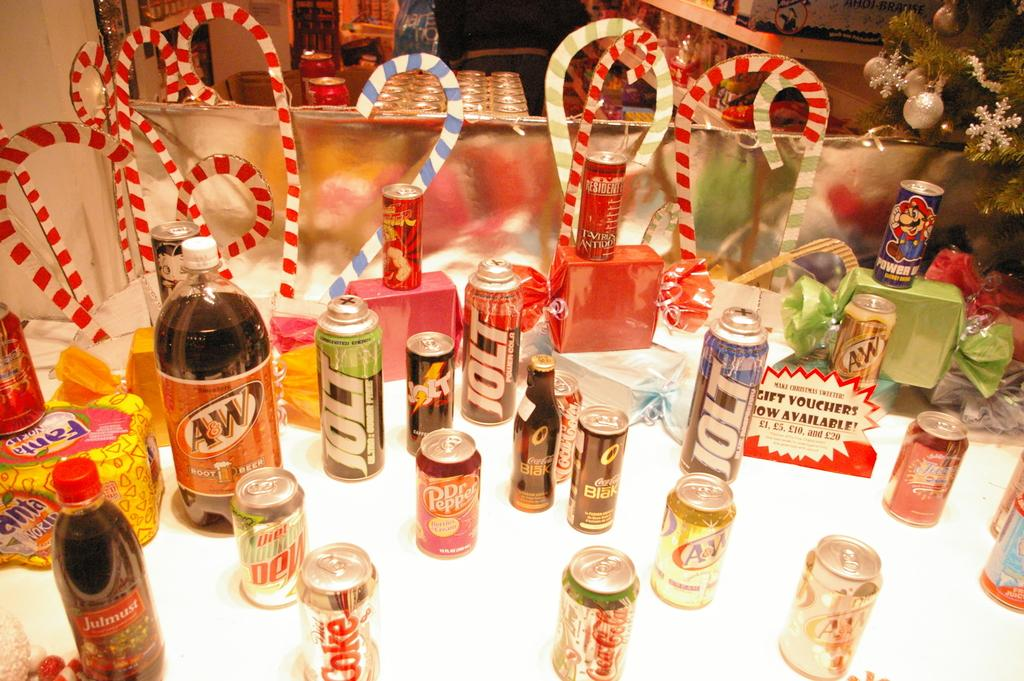What type of beverages are present in the image? There are cold drink cans and cold drink bottles in the image. What type of snack is present in the image? There are candy sticks in the image. Where are these items located in the image? All items are kept on a table. What type of debt can be seen in the image? There is no debt present in the image; it features cold drink cans, cold drink bottles, and candy sticks on a table. What type of copper material is visible in the image? There is no copper material present in the image. 